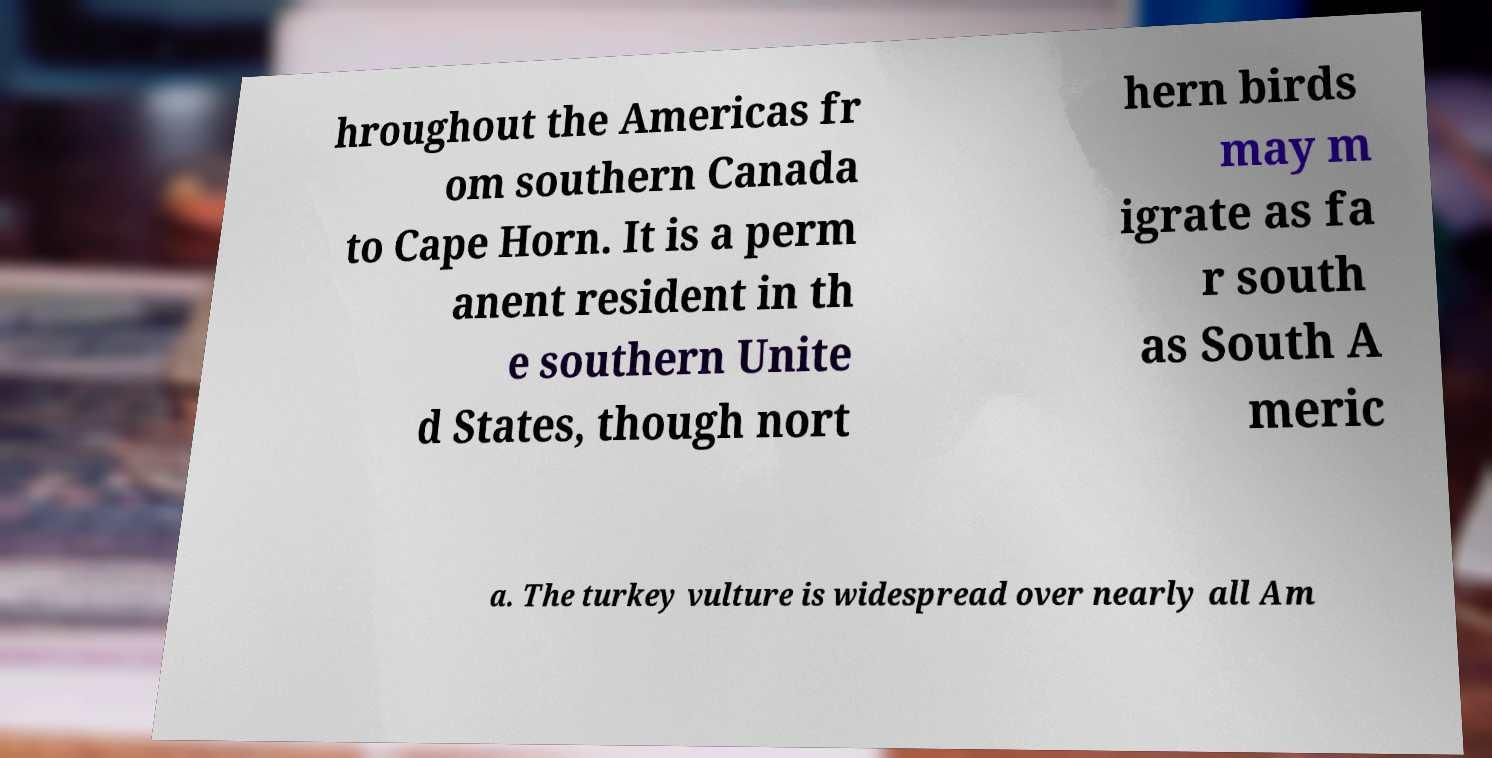Could you assist in decoding the text presented in this image and type it out clearly? hroughout the Americas fr om southern Canada to Cape Horn. It is a perm anent resident in th e southern Unite d States, though nort hern birds may m igrate as fa r south as South A meric a. The turkey vulture is widespread over nearly all Am 